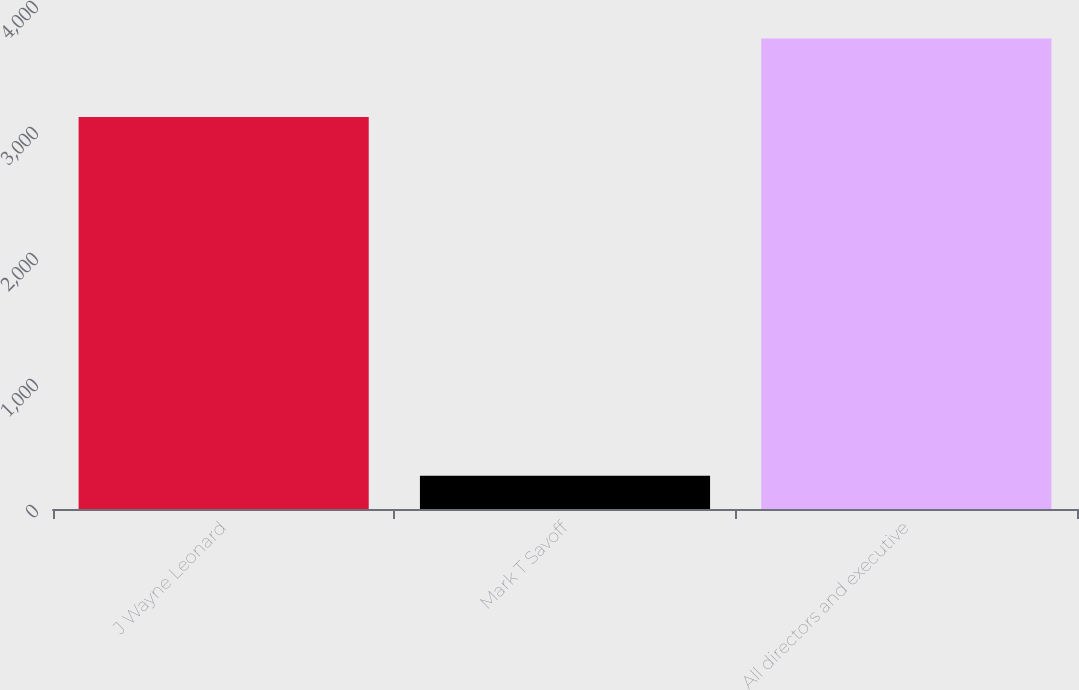<chart> <loc_0><loc_0><loc_500><loc_500><bar_chart><fcel>J Wayne Leonard<fcel>Mark T Savoff<fcel>All directors and executive<nl><fcel>3111<fcel>263<fcel>3733.2<nl></chart> 